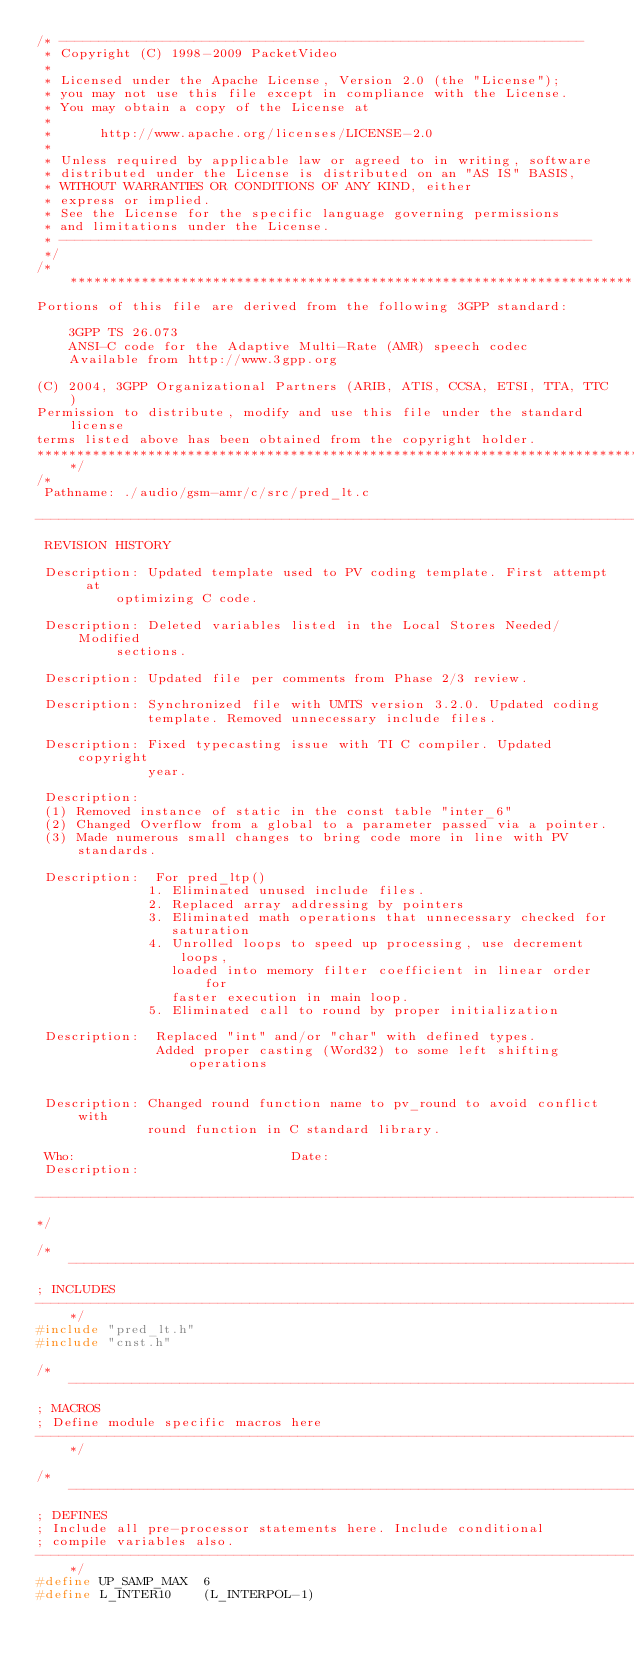<code> <loc_0><loc_0><loc_500><loc_500><_C++_>/* ------------------------------------------------------------------
 * Copyright (C) 1998-2009 PacketVideo
 *
 * Licensed under the Apache License, Version 2.0 (the "License");
 * you may not use this file except in compliance with the License.
 * You may obtain a copy of the License at
 *
 *      http://www.apache.org/licenses/LICENSE-2.0
 *
 * Unless required by applicable law or agreed to in writing, software
 * distributed under the License is distributed on an "AS IS" BASIS,
 * WITHOUT WARRANTIES OR CONDITIONS OF ANY KIND, either
 * express or implied.
 * See the License for the specific language governing permissions
 * and limitations under the License.
 * -------------------------------------------------------------------
 */
/****************************************************************************************
Portions of this file are derived from the following 3GPP standard:

    3GPP TS 26.073
    ANSI-C code for the Adaptive Multi-Rate (AMR) speech codec
    Available from http://www.3gpp.org

(C) 2004, 3GPP Organizational Partners (ARIB, ATIS, CCSA, ETSI, TTA, TTC)
Permission to distribute, modify and use this file under the standard license
terms listed above has been obtained from the copyright holder.
****************************************************************************************/
/*
 Pathname: ./audio/gsm-amr/c/src/pred_lt.c

------------------------------------------------------------------------------
 REVISION HISTORY

 Description: Updated template used to PV coding template. First attempt at
          optimizing C code.

 Description: Deleted variables listed in the Local Stores Needed/Modified
          sections.

 Description: Updated file per comments from Phase 2/3 review.

 Description: Synchronized file with UMTS version 3.2.0. Updated coding
              template. Removed unnecessary include files.

 Description: Fixed typecasting issue with TI C compiler. Updated copyright
              year.

 Description:
 (1) Removed instance of static in the const table "inter_6"
 (2) Changed Overflow from a global to a parameter passed via a pointer.
 (3) Made numerous small changes to bring code more in line with PV standards.

 Description:  For pred_ltp()
              1. Eliminated unused include files.
              2. Replaced array addressing by pointers
              3. Eliminated math operations that unnecessary checked for
                 saturation
              4. Unrolled loops to speed up processing, use decrement loops,
                 loaded into memory filter coefficient in linear order for
                 faster execution in main loop.
              5. Eliminated call to round by proper initialization

 Description:  Replaced "int" and/or "char" with defined types.
               Added proper casting (Word32) to some left shifting operations


 Description: Changed round function name to pv_round to avoid conflict with
              round function in C standard library.

 Who:                           Date:
 Description:

------------------------------------------------------------------------------
*/

/*----------------------------------------------------------------------------
; INCLUDES
----------------------------------------------------------------------------*/
#include "pred_lt.h"
#include "cnst.h"

/*----------------------------------------------------------------------------
; MACROS
; Define module specific macros here
----------------------------------------------------------------------------*/

/*----------------------------------------------------------------------------
; DEFINES
; Include all pre-processor statements here. Include conditional
; compile variables also.
----------------------------------------------------------------------------*/
#define UP_SAMP_MAX  6
#define L_INTER10    (L_INTERPOL-1)</code> 